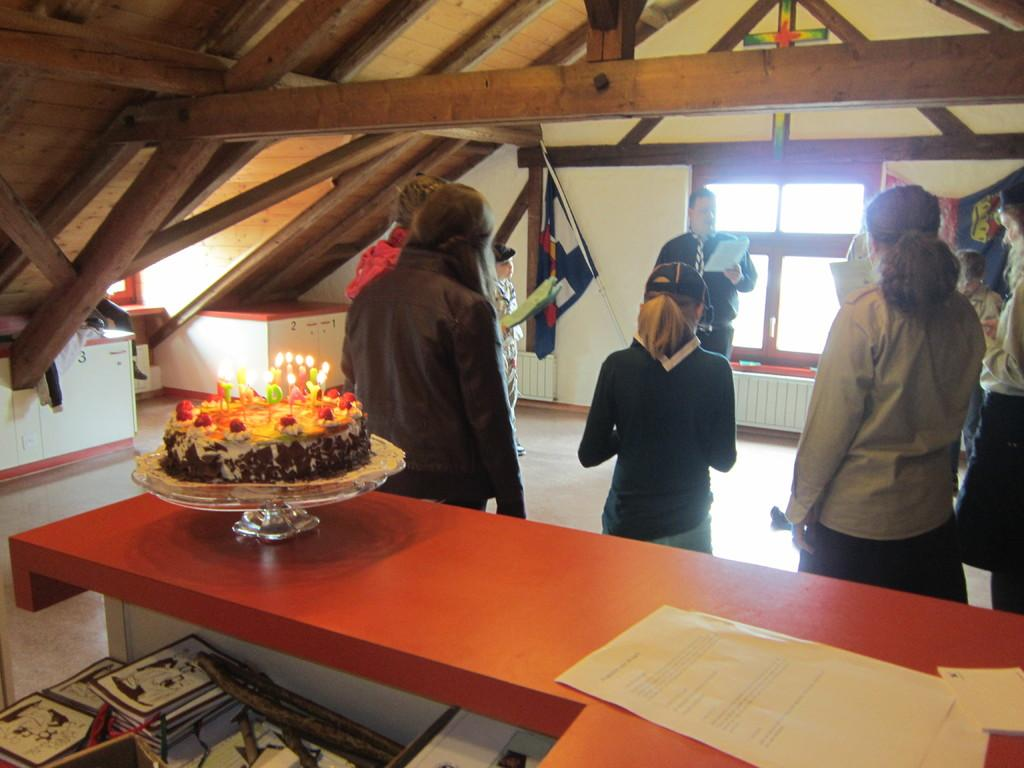What is the main setting of the image? There is a room in the image. What are the people in the image doing? The people are standing in the room. Where are the people standing in relation to the table? The people are standing in front of a table. What is on the table in the image? There is a cake and papers on the table. What type of jam is being used to fuel the engine in the image? There is no jam or engine present in the image. How many people are joining the group in the image? The image does not show any additional people joining the group; it only depicts the people who are already standing in the room. 